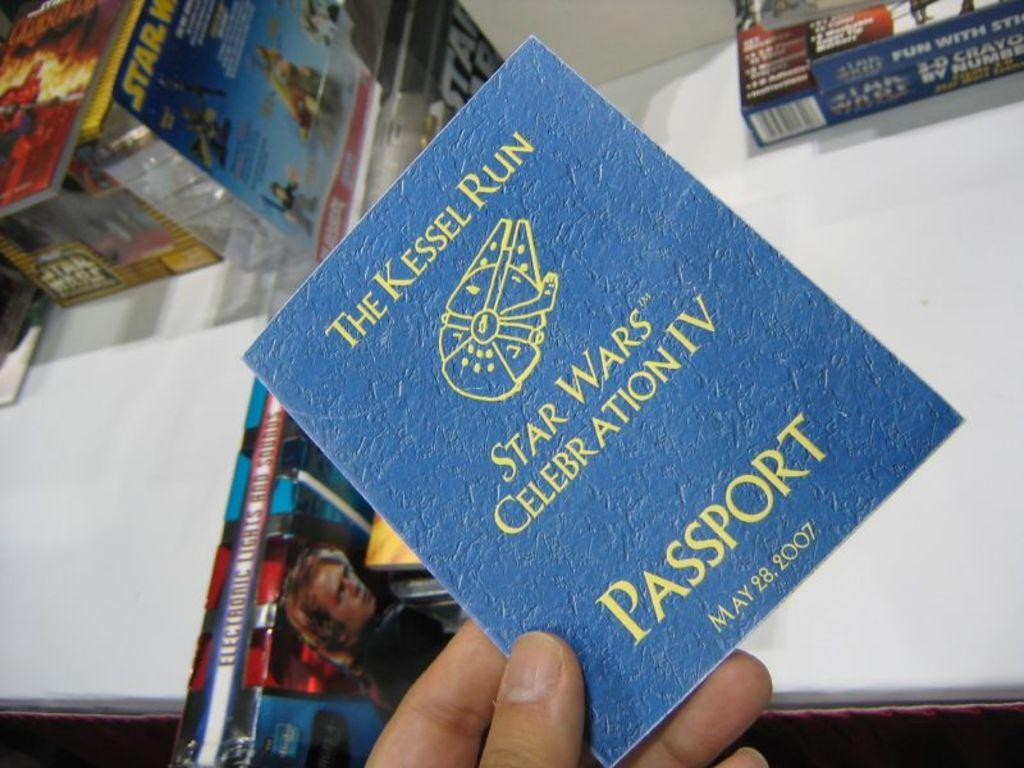<image>
Render a clear and concise summary of the photo. A hand is holding a passport for The Kessel Run. 